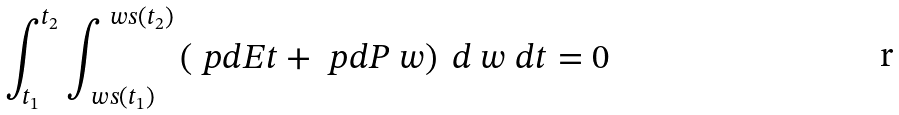Convert formula to latex. <formula><loc_0><loc_0><loc_500><loc_500>\int _ { t _ { 1 } } ^ { t _ { 2 } } \int _ { \ w s ( t _ { 1 } ) } ^ { \ w s ( t _ { 2 } ) } \left ( \ p d { E } { t } + \ p d { P } { \ w } \right ) \ d \ w \ d t = 0</formula> 